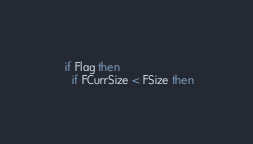<code> <loc_0><loc_0><loc_500><loc_500><_Pascal_>  if Flag then
    if FCurrSize < FSize then</code> 